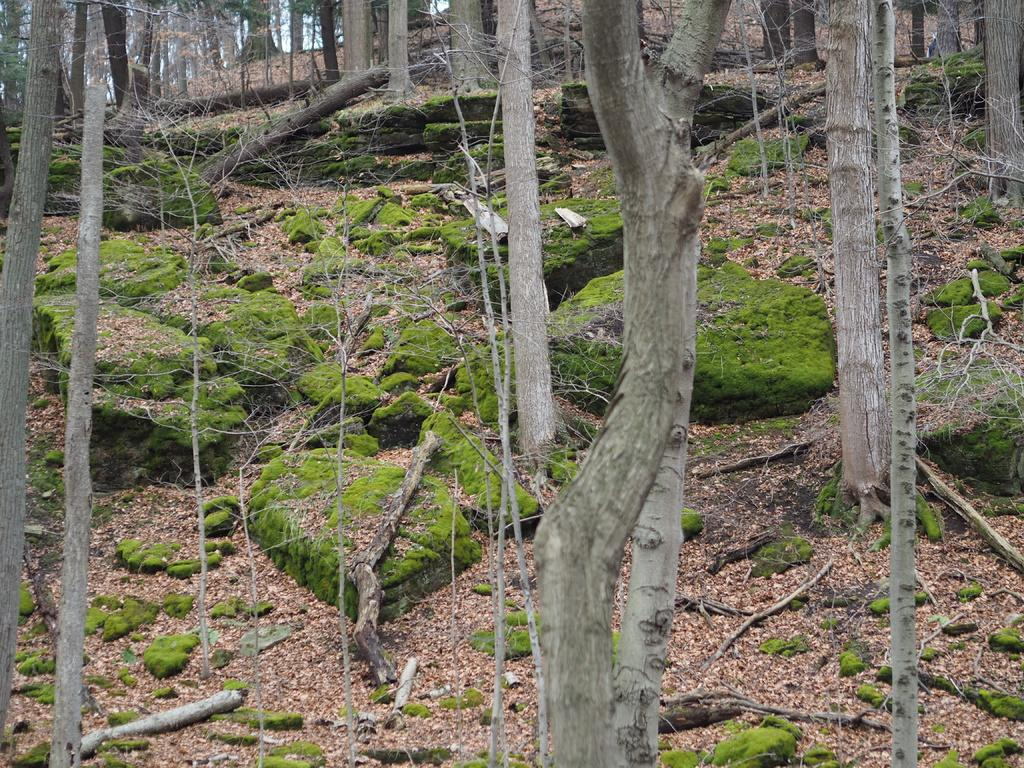What type of vegetation can be seen in the image? There are trees in the image. What is the ground covered with in the image? There is grass visible in the image. What objects made of wood can be seen in the image? There are sticks in the image. What color is the sky in the image? The sky is blue in color. How many cherries are hanging from the trees in the image? There are no cherries present in the image; it only features trees, grass, sticks, and a blue sky. What type of silver object can be seen in the image? There is no silver object present in the image. 